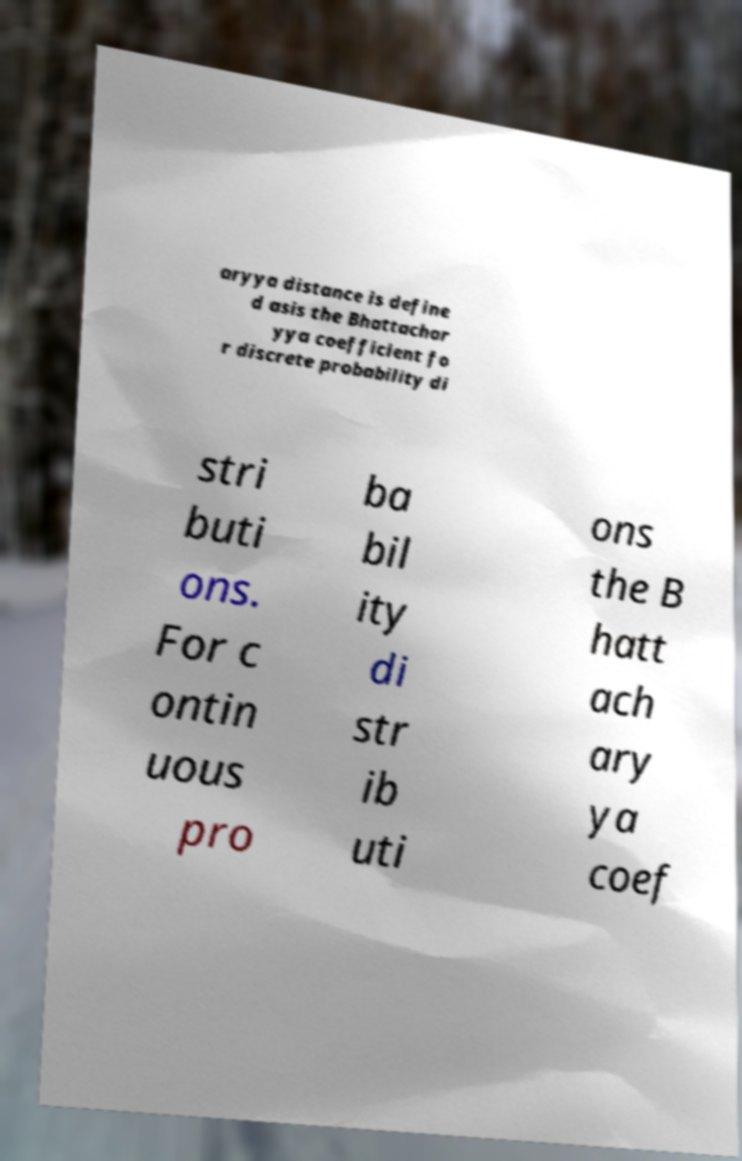I need the written content from this picture converted into text. Can you do that? aryya distance is define d asis the Bhattachar yya coefficient fo r discrete probability di stri buti ons. For c ontin uous pro ba bil ity di str ib uti ons the B hatt ach ary ya coef 